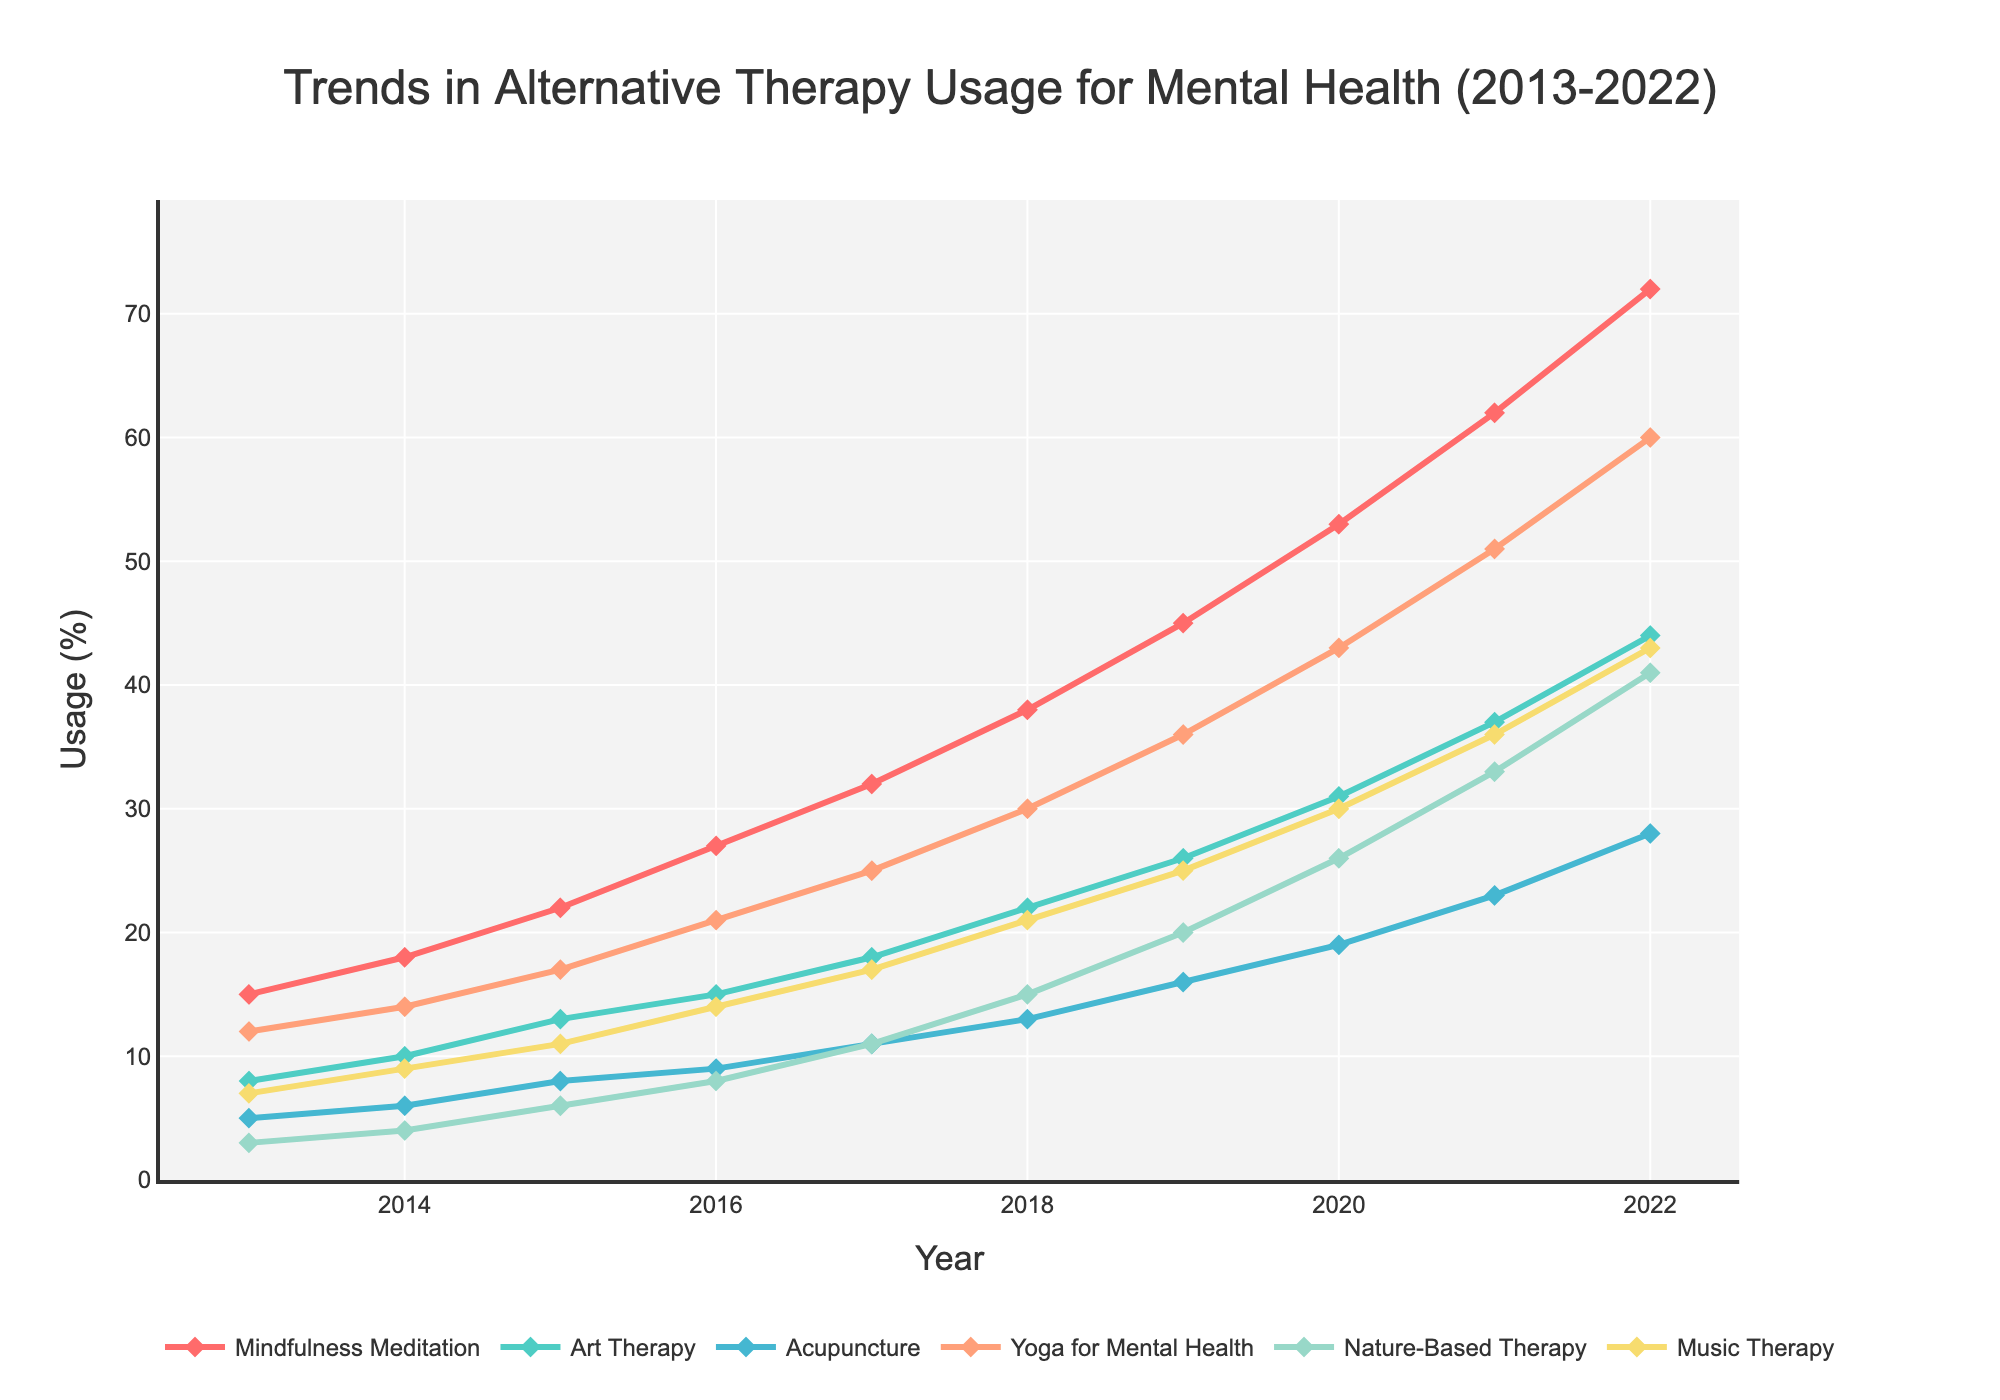What therapy type had the highest usage in 2022? Look at the usage percentages for all therapy types in 2022. Mindfulness Meditation has the highest value at 72%.
Answer: Mindfulness Meditation Which therapy type saw the greatest increase in usage from 2013 to 2022? Calculate the difference in usage for each therapy type between 2013 and 2022. Mindfulness Meditation increased by 72 - 15 = 57%, which is the highest among all the therapy types.
Answer: Mindfulness Meditation Between 2017 and 2018, which therapy type had the largest increase in percentage usage? Check the differences in usage between 2017 and 2018 for all therapy types. Mindfulness Meditation increased by 38 - 32 = 6%, which is the largest increase in this period.
Answer: Mindfulness Meditation What is the average usage of Yoga for Mental Health over the given years? Add up the usage values for Yoga for Mental Health from 2013 to 2022 and divide by the number of years (10). (12 + 14 + 17 + 21 + 25 + 30 + 36 + 43 + 51 + 60) / 10 = 30.9%.
Answer: 30.9% Which therapy type had a similar increase in usage between 2019 and 2022 as Music Therapy? Find the increase in usage for Music Therapy from 2019 to 2022, which is 43 - 25 = 18%. Then find similar increases in other therapy types. Art Therapy increased from 26 to 44 (18%) in the same period.
Answer: Art Therapy What is the difference in percentage usage between Acupuncture and Nature-Based Therapy in 2020? Look at the values for Acupuncture and Nature-Based Therapy in 2020, which are 19% and 26%, respectively. The difference is 26 - 19 = 7%.
Answer: 7% How much did the usage of Nature-Based Therapy change from 2013 to 2020? Subtract the 2013 value of Nature-Based Therapy from the 2020 value. 26 - 3 = 23%.
Answer: 23% In which year did Art Therapy surpass Acupuncture in usage? Compare the annual usage values of Art Therapy and Acupuncture to find the first year Art Therapy's value is higher. In 2014, Art Therapy (10%) surpassed Acupuncture (6%).
Answer: 2014 If we combine the usage of Music Therapy and Art Therapy in 2022, what is the total usage percentage? Add the 2022 usage values for Music Therapy and Art Therapy. 43 + 44 = 87%.
Answer: 87% Which therapy type showed a consistent increase in usage every year from 2013 to 2022? Check the usage values of each therapy type for every year to see if they increased every year. All the therapy types show a consistent increase.
Answer: All Therapy Types 